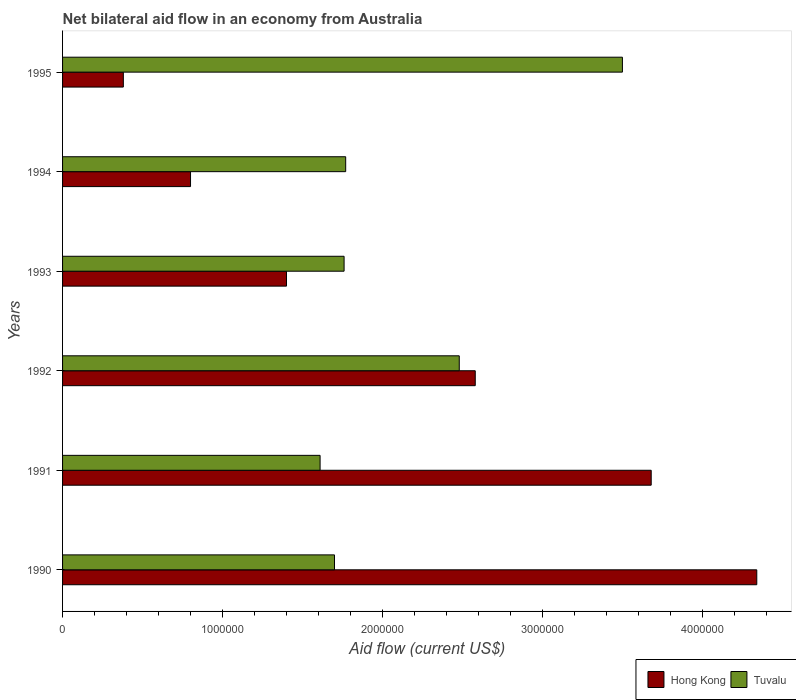How many different coloured bars are there?
Your response must be concise. 2. Are the number of bars on each tick of the Y-axis equal?
Provide a succinct answer. Yes. How many bars are there on the 3rd tick from the top?
Provide a short and direct response. 2. How many bars are there on the 6th tick from the bottom?
Make the answer very short. 2. In how many cases, is the number of bars for a given year not equal to the number of legend labels?
Ensure brevity in your answer.  0. What is the net bilateral aid flow in Hong Kong in 1990?
Ensure brevity in your answer.  4.34e+06. Across all years, what is the maximum net bilateral aid flow in Tuvalu?
Ensure brevity in your answer.  3.50e+06. Across all years, what is the minimum net bilateral aid flow in Tuvalu?
Give a very brief answer. 1.61e+06. In which year was the net bilateral aid flow in Tuvalu maximum?
Keep it short and to the point. 1995. What is the total net bilateral aid flow in Hong Kong in the graph?
Provide a short and direct response. 1.32e+07. What is the difference between the net bilateral aid flow in Hong Kong in 1990 and that in 1995?
Give a very brief answer. 3.96e+06. What is the average net bilateral aid flow in Hong Kong per year?
Your answer should be compact. 2.20e+06. In how many years, is the net bilateral aid flow in Tuvalu greater than 2400000 US$?
Your answer should be compact. 2. What is the ratio of the net bilateral aid flow in Hong Kong in 1992 to that in 1995?
Ensure brevity in your answer.  6.79. Is the difference between the net bilateral aid flow in Hong Kong in 1990 and 1995 greater than the difference between the net bilateral aid flow in Tuvalu in 1990 and 1995?
Offer a very short reply. Yes. What is the difference between the highest and the second highest net bilateral aid flow in Tuvalu?
Provide a short and direct response. 1.02e+06. What is the difference between the highest and the lowest net bilateral aid flow in Hong Kong?
Offer a terse response. 3.96e+06. Is the sum of the net bilateral aid flow in Hong Kong in 1990 and 1993 greater than the maximum net bilateral aid flow in Tuvalu across all years?
Provide a short and direct response. Yes. What does the 2nd bar from the top in 1991 represents?
Keep it short and to the point. Hong Kong. What does the 2nd bar from the bottom in 1991 represents?
Provide a succinct answer. Tuvalu. How many bars are there?
Your answer should be very brief. 12. Are all the bars in the graph horizontal?
Provide a succinct answer. Yes. How many years are there in the graph?
Offer a terse response. 6. Are the values on the major ticks of X-axis written in scientific E-notation?
Give a very brief answer. No. Does the graph contain any zero values?
Make the answer very short. No. How are the legend labels stacked?
Your response must be concise. Horizontal. What is the title of the graph?
Provide a short and direct response. Net bilateral aid flow in an economy from Australia. What is the Aid flow (current US$) in Hong Kong in 1990?
Provide a succinct answer. 4.34e+06. What is the Aid flow (current US$) in Tuvalu in 1990?
Your answer should be compact. 1.70e+06. What is the Aid flow (current US$) in Hong Kong in 1991?
Keep it short and to the point. 3.68e+06. What is the Aid flow (current US$) of Tuvalu in 1991?
Provide a short and direct response. 1.61e+06. What is the Aid flow (current US$) in Hong Kong in 1992?
Keep it short and to the point. 2.58e+06. What is the Aid flow (current US$) of Tuvalu in 1992?
Offer a terse response. 2.48e+06. What is the Aid flow (current US$) of Hong Kong in 1993?
Offer a very short reply. 1.40e+06. What is the Aid flow (current US$) of Tuvalu in 1993?
Your answer should be compact. 1.76e+06. What is the Aid flow (current US$) of Hong Kong in 1994?
Give a very brief answer. 8.00e+05. What is the Aid flow (current US$) in Tuvalu in 1994?
Give a very brief answer. 1.77e+06. What is the Aid flow (current US$) of Tuvalu in 1995?
Your answer should be very brief. 3.50e+06. Across all years, what is the maximum Aid flow (current US$) of Hong Kong?
Your answer should be compact. 4.34e+06. Across all years, what is the maximum Aid flow (current US$) in Tuvalu?
Provide a short and direct response. 3.50e+06. Across all years, what is the minimum Aid flow (current US$) of Hong Kong?
Provide a short and direct response. 3.80e+05. Across all years, what is the minimum Aid flow (current US$) of Tuvalu?
Give a very brief answer. 1.61e+06. What is the total Aid flow (current US$) of Hong Kong in the graph?
Offer a terse response. 1.32e+07. What is the total Aid flow (current US$) in Tuvalu in the graph?
Keep it short and to the point. 1.28e+07. What is the difference between the Aid flow (current US$) of Tuvalu in 1990 and that in 1991?
Give a very brief answer. 9.00e+04. What is the difference between the Aid flow (current US$) of Hong Kong in 1990 and that in 1992?
Your response must be concise. 1.76e+06. What is the difference between the Aid flow (current US$) of Tuvalu in 1990 and that in 1992?
Your answer should be very brief. -7.80e+05. What is the difference between the Aid flow (current US$) in Hong Kong in 1990 and that in 1993?
Your answer should be compact. 2.94e+06. What is the difference between the Aid flow (current US$) in Tuvalu in 1990 and that in 1993?
Provide a short and direct response. -6.00e+04. What is the difference between the Aid flow (current US$) in Hong Kong in 1990 and that in 1994?
Provide a short and direct response. 3.54e+06. What is the difference between the Aid flow (current US$) in Tuvalu in 1990 and that in 1994?
Your answer should be compact. -7.00e+04. What is the difference between the Aid flow (current US$) in Hong Kong in 1990 and that in 1995?
Keep it short and to the point. 3.96e+06. What is the difference between the Aid flow (current US$) of Tuvalu in 1990 and that in 1995?
Offer a very short reply. -1.80e+06. What is the difference between the Aid flow (current US$) in Hong Kong in 1991 and that in 1992?
Keep it short and to the point. 1.10e+06. What is the difference between the Aid flow (current US$) in Tuvalu in 1991 and that in 1992?
Your answer should be compact. -8.70e+05. What is the difference between the Aid flow (current US$) in Hong Kong in 1991 and that in 1993?
Keep it short and to the point. 2.28e+06. What is the difference between the Aid flow (current US$) of Hong Kong in 1991 and that in 1994?
Provide a succinct answer. 2.88e+06. What is the difference between the Aid flow (current US$) in Tuvalu in 1991 and that in 1994?
Provide a succinct answer. -1.60e+05. What is the difference between the Aid flow (current US$) of Hong Kong in 1991 and that in 1995?
Give a very brief answer. 3.30e+06. What is the difference between the Aid flow (current US$) in Tuvalu in 1991 and that in 1995?
Provide a short and direct response. -1.89e+06. What is the difference between the Aid flow (current US$) of Hong Kong in 1992 and that in 1993?
Ensure brevity in your answer.  1.18e+06. What is the difference between the Aid flow (current US$) in Tuvalu in 1992 and that in 1993?
Your response must be concise. 7.20e+05. What is the difference between the Aid flow (current US$) of Hong Kong in 1992 and that in 1994?
Offer a terse response. 1.78e+06. What is the difference between the Aid flow (current US$) of Tuvalu in 1992 and that in 1994?
Offer a terse response. 7.10e+05. What is the difference between the Aid flow (current US$) in Hong Kong in 1992 and that in 1995?
Offer a terse response. 2.20e+06. What is the difference between the Aid flow (current US$) of Tuvalu in 1992 and that in 1995?
Make the answer very short. -1.02e+06. What is the difference between the Aid flow (current US$) of Hong Kong in 1993 and that in 1994?
Your answer should be very brief. 6.00e+05. What is the difference between the Aid flow (current US$) of Hong Kong in 1993 and that in 1995?
Offer a terse response. 1.02e+06. What is the difference between the Aid flow (current US$) of Tuvalu in 1993 and that in 1995?
Offer a terse response. -1.74e+06. What is the difference between the Aid flow (current US$) of Hong Kong in 1994 and that in 1995?
Provide a short and direct response. 4.20e+05. What is the difference between the Aid flow (current US$) in Tuvalu in 1994 and that in 1995?
Offer a terse response. -1.73e+06. What is the difference between the Aid flow (current US$) in Hong Kong in 1990 and the Aid flow (current US$) in Tuvalu in 1991?
Make the answer very short. 2.73e+06. What is the difference between the Aid flow (current US$) of Hong Kong in 1990 and the Aid flow (current US$) of Tuvalu in 1992?
Your answer should be very brief. 1.86e+06. What is the difference between the Aid flow (current US$) of Hong Kong in 1990 and the Aid flow (current US$) of Tuvalu in 1993?
Offer a very short reply. 2.58e+06. What is the difference between the Aid flow (current US$) in Hong Kong in 1990 and the Aid flow (current US$) in Tuvalu in 1994?
Provide a succinct answer. 2.57e+06. What is the difference between the Aid flow (current US$) of Hong Kong in 1990 and the Aid flow (current US$) of Tuvalu in 1995?
Provide a short and direct response. 8.40e+05. What is the difference between the Aid flow (current US$) of Hong Kong in 1991 and the Aid flow (current US$) of Tuvalu in 1992?
Offer a terse response. 1.20e+06. What is the difference between the Aid flow (current US$) in Hong Kong in 1991 and the Aid flow (current US$) in Tuvalu in 1993?
Offer a terse response. 1.92e+06. What is the difference between the Aid flow (current US$) in Hong Kong in 1991 and the Aid flow (current US$) in Tuvalu in 1994?
Offer a very short reply. 1.91e+06. What is the difference between the Aid flow (current US$) of Hong Kong in 1991 and the Aid flow (current US$) of Tuvalu in 1995?
Ensure brevity in your answer.  1.80e+05. What is the difference between the Aid flow (current US$) in Hong Kong in 1992 and the Aid flow (current US$) in Tuvalu in 1993?
Make the answer very short. 8.20e+05. What is the difference between the Aid flow (current US$) of Hong Kong in 1992 and the Aid flow (current US$) of Tuvalu in 1994?
Provide a succinct answer. 8.10e+05. What is the difference between the Aid flow (current US$) of Hong Kong in 1992 and the Aid flow (current US$) of Tuvalu in 1995?
Provide a succinct answer. -9.20e+05. What is the difference between the Aid flow (current US$) of Hong Kong in 1993 and the Aid flow (current US$) of Tuvalu in 1994?
Give a very brief answer. -3.70e+05. What is the difference between the Aid flow (current US$) of Hong Kong in 1993 and the Aid flow (current US$) of Tuvalu in 1995?
Make the answer very short. -2.10e+06. What is the difference between the Aid flow (current US$) in Hong Kong in 1994 and the Aid flow (current US$) in Tuvalu in 1995?
Offer a very short reply. -2.70e+06. What is the average Aid flow (current US$) in Hong Kong per year?
Offer a very short reply. 2.20e+06. What is the average Aid flow (current US$) in Tuvalu per year?
Your response must be concise. 2.14e+06. In the year 1990, what is the difference between the Aid flow (current US$) of Hong Kong and Aid flow (current US$) of Tuvalu?
Provide a succinct answer. 2.64e+06. In the year 1991, what is the difference between the Aid flow (current US$) of Hong Kong and Aid flow (current US$) of Tuvalu?
Your response must be concise. 2.07e+06. In the year 1993, what is the difference between the Aid flow (current US$) of Hong Kong and Aid flow (current US$) of Tuvalu?
Your answer should be compact. -3.60e+05. In the year 1994, what is the difference between the Aid flow (current US$) of Hong Kong and Aid flow (current US$) of Tuvalu?
Keep it short and to the point. -9.70e+05. In the year 1995, what is the difference between the Aid flow (current US$) in Hong Kong and Aid flow (current US$) in Tuvalu?
Make the answer very short. -3.12e+06. What is the ratio of the Aid flow (current US$) in Hong Kong in 1990 to that in 1991?
Give a very brief answer. 1.18. What is the ratio of the Aid flow (current US$) in Tuvalu in 1990 to that in 1991?
Give a very brief answer. 1.06. What is the ratio of the Aid flow (current US$) of Hong Kong in 1990 to that in 1992?
Offer a very short reply. 1.68. What is the ratio of the Aid flow (current US$) of Tuvalu in 1990 to that in 1992?
Offer a terse response. 0.69. What is the ratio of the Aid flow (current US$) of Tuvalu in 1990 to that in 1993?
Your response must be concise. 0.97. What is the ratio of the Aid flow (current US$) of Hong Kong in 1990 to that in 1994?
Offer a very short reply. 5.42. What is the ratio of the Aid flow (current US$) of Tuvalu in 1990 to that in 1994?
Make the answer very short. 0.96. What is the ratio of the Aid flow (current US$) of Hong Kong in 1990 to that in 1995?
Your answer should be very brief. 11.42. What is the ratio of the Aid flow (current US$) of Tuvalu in 1990 to that in 1995?
Your answer should be very brief. 0.49. What is the ratio of the Aid flow (current US$) of Hong Kong in 1991 to that in 1992?
Make the answer very short. 1.43. What is the ratio of the Aid flow (current US$) of Tuvalu in 1991 to that in 1992?
Keep it short and to the point. 0.65. What is the ratio of the Aid flow (current US$) of Hong Kong in 1991 to that in 1993?
Keep it short and to the point. 2.63. What is the ratio of the Aid flow (current US$) in Tuvalu in 1991 to that in 1993?
Your answer should be very brief. 0.91. What is the ratio of the Aid flow (current US$) in Hong Kong in 1991 to that in 1994?
Your answer should be very brief. 4.6. What is the ratio of the Aid flow (current US$) of Tuvalu in 1991 to that in 1994?
Offer a very short reply. 0.91. What is the ratio of the Aid flow (current US$) in Hong Kong in 1991 to that in 1995?
Offer a very short reply. 9.68. What is the ratio of the Aid flow (current US$) in Tuvalu in 1991 to that in 1995?
Offer a terse response. 0.46. What is the ratio of the Aid flow (current US$) in Hong Kong in 1992 to that in 1993?
Provide a succinct answer. 1.84. What is the ratio of the Aid flow (current US$) of Tuvalu in 1992 to that in 1993?
Your response must be concise. 1.41. What is the ratio of the Aid flow (current US$) of Hong Kong in 1992 to that in 1994?
Your answer should be compact. 3.23. What is the ratio of the Aid flow (current US$) in Tuvalu in 1992 to that in 1994?
Provide a short and direct response. 1.4. What is the ratio of the Aid flow (current US$) in Hong Kong in 1992 to that in 1995?
Your answer should be very brief. 6.79. What is the ratio of the Aid flow (current US$) of Tuvalu in 1992 to that in 1995?
Provide a succinct answer. 0.71. What is the ratio of the Aid flow (current US$) of Tuvalu in 1993 to that in 1994?
Make the answer very short. 0.99. What is the ratio of the Aid flow (current US$) of Hong Kong in 1993 to that in 1995?
Keep it short and to the point. 3.68. What is the ratio of the Aid flow (current US$) in Tuvalu in 1993 to that in 1995?
Provide a short and direct response. 0.5. What is the ratio of the Aid flow (current US$) of Hong Kong in 1994 to that in 1995?
Keep it short and to the point. 2.11. What is the ratio of the Aid flow (current US$) of Tuvalu in 1994 to that in 1995?
Ensure brevity in your answer.  0.51. What is the difference between the highest and the second highest Aid flow (current US$) of Hong Kong?
Your answer should be very brief. 6.60e+05. What is the difference between the highest and the second highest Aid flow (current US$) in Tuvalu?
Your answer should be very brief. 1.02e+06. What is the difference between the highest and the lowest Aid flow (current US$) in Hong Kong?
Give a very brief answer. 3.96e+06. What is the difference between the highest and the lowest Aid flow (current US$) in Tuvalu?
Your response must be concise. 1.89e+06. 